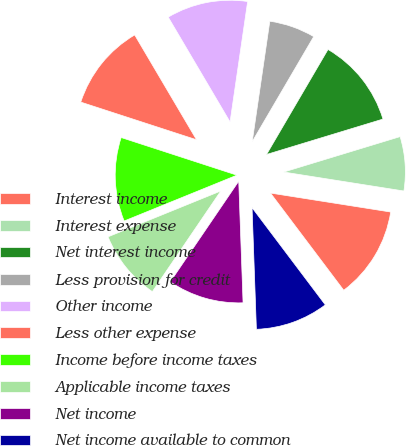<chart> <loc_0><loc_0><loc_500><loc_500><pie_chart><fcel>Interest income<fcel>Interest expense<fcel>Net interest income<fcel>Less provision for credit<fcel>Other income<fcel>Less other expense<fcel>Income before income taxes<fcel>Applicable income taxes<fcel>Net income<fcel>Net income available to common<nl><fcel>12.23%<fcel>7.19%<fcel>11.87%<fcel>6.12%<fcel>10.79%<fcel>11.51%<fcel>11.15%<fcel>9.35%<fcel>10.07%<fcel>9.71%<nl></chart> 